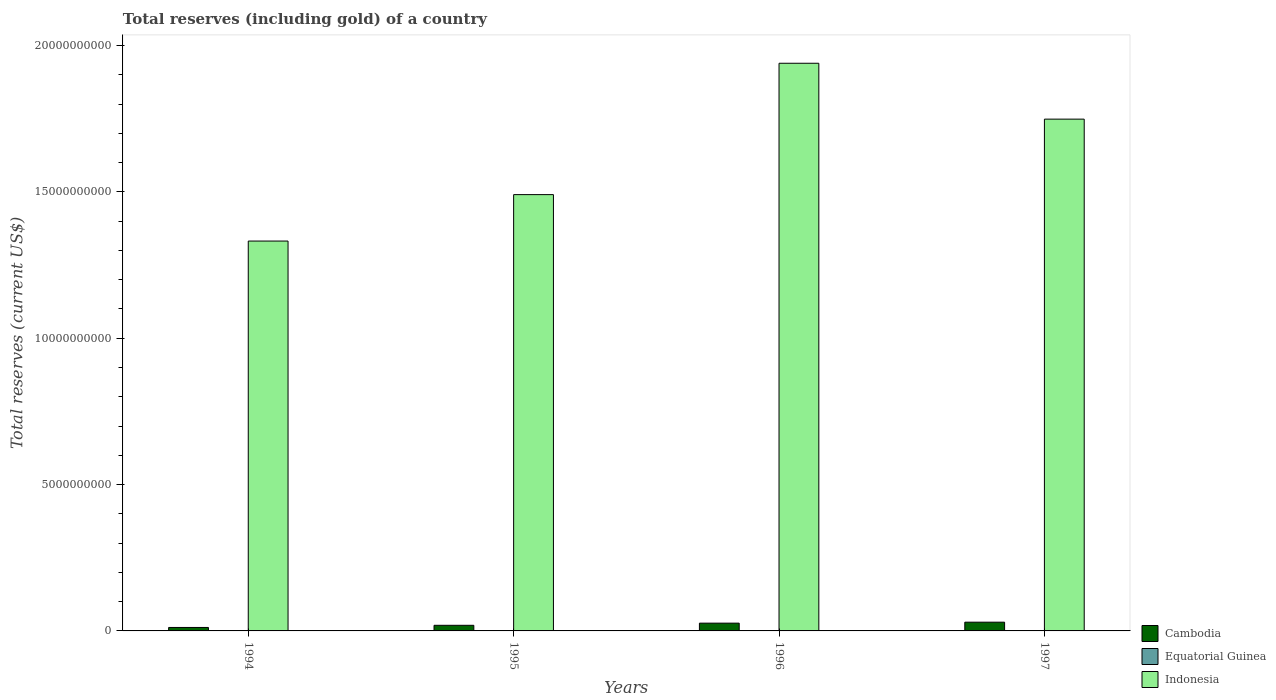How many groups of bars are there?
Offer a very short reply. 4. Are the number of bars per tick equal to the number of legend labels?
Your answer should be compact. Yes. Are the number of bars on each tick of the X-axis equal?
Keep it short and to the point. Yes. In how many cases, is the number of bars for a given year not equal to the number of legend labels?
Your answer should be very brief. 0. What is the total reserves (including gold) in Cambodia in 1997?
Provide a succinct answer. 2.99e+08. Across all years, what is the maximum total reserves (including gold) in Equatorial Guinea?
Your answer should be compact. 4.93e+06. Across all years, what is the minimum total reserves (including gold) in Equatorial Guinea?
Your response must be concise. 4.08e+04. In which year was the total reserves (including gold) in Indonesia minimum?
Make the answer very short. 1994. What is the total total reserves (including gold) in Cambodia in the graph?
Ensure brevity in your answer.  8.75e+08. What is the difference between the total reserves (including gold) in Equatorial Guinea in 1996 and that in 1997?
Give a very brief answer. -4.42e+06. What is the difference between the total reserves (including gold) in Equatorial Guinea in 1997 and the total reserves (including gold) in Cambodia in 1995?
Your response must be concise. -1.87e+08. What is the average total reserves (including gold) in Equatorial Guinea per year?
Give a very brief answer. 1.47e+06. In the year 1994, what is the difference between the total reserves (including gold) in Equatorial Guinea and total reserves (including gold) in Cambodia?
Offer a terse response. -1.18e+08. In how many years, is the total reserves (including gold) in Cambodia greater than 4000000000 US$?
Provide a short and direct response. 0. What is the ratio of the total reserves (including gold) in Cambodia in 1995 to that in 1997?
Your response must be concise. 0.64. What is the difference between the highest and the second highest total reserves (including gold) in Cambodia?
Your response must be concise. 3.29e+07. What is the difference between the highest and the lowest total reserves (including gold) in Cambodia?
Keep it short and to the point. 1.80e+08. In how many years, is the total reserves (including gold) in Cambodia greater than the average total reserves (including gold) in Cambodia taken over all years?
Your answer should be very brief. 2. Is the sum of the total reserves (including gold) in Indonesia in 1994 and 1997 greater than the maximum total reserves (including gold) in Cambodia across all years?
Give a very brief answer. Yes. What does the 1st bar from the left in 1994 represents?
Offer a terse response. Cambodia. Are all the bars in the graph horizontal?
Ensure brevity in your answer.  No. Does the graph contain any zero values?
Your response must be concise. No. Does the graph contain grids?
Your answer should be compact. No. What is the title of the graph?
Offer a very short reply. Total reserves (including gold) of a country. What is the label or title of the X-axis?
Ensure brevity in your answer.  Years. What is the label or title of the Y-axis?
Make the answer very short. Total reserves (current US$). What is the Total reserves (current US$) in Cambodia in 1994?
Offer a terse response. 1.18e+08. What is the Total reserves (current US$) in Equatorial Guinea in 1994?
Offer a terse response. 3.90e+05. What is the Total reserves (current US$) in Indonesia in 1994?
Your response must be concise. 1.33e+1. What is the Total reserves (current US$) in Cambodia in 1995?
Make the answer very short. 1.92e+08. What is the Total reserves (current US$) in Equatorial Guinea in 1995?
Provide a succinct answer. 4.08e+04. What is the Total reserves (current US$) in Indonesia in 1995?
Provide a succinct answer. 1.49e+1. What is the Total reserves (current US$) in Cambodia in 1996?
Your answer should be compact. 2.66e+08. What is the Total reserves (current US$) of Equatorial Guinea in 1996?
Ensure brevity in your answer.  5.16e+05. What is the Total reserves (current US$) in Indonesia in 1996?
Provide a succinct answer. 1.94e+1. What is the Total reserves (current US$) of Cambodia in 1997?
Your response must be concise. 2.99e+08. What is the Total reserves (current US$) of Equatorial Guinea in 1997?
Offer a very short reply. 4.93e+06. What is the Total reserves (current US$) in Indonesia in 1997?
Provide a short and direct response. 1.75e+1. Across all years, what is the maximum Total reserves (current US$) of Cambodia?
Your answer should be compact. 2.99e+08. Across all years, what is the maximum Total reserves (current US$) in Equatorial Guinea?
Make the answer very short. 4.93e+06. Across all years, what is the maximum Total reserves (current US$) of Indonesia?
Your answer should be very brief. 1.94e+1. Across all years, what is the minimum Total reserves (current US$) in Cambodia?
Your answer should be compact. 1.18e+08. Across all years, what is the minimum Total reserves (current US$) in Equatorial Guinea?
Your answer should be very brief. 4.08e+04. Across all years, what is the minimum Total reserves (current US$) of Indonesia?
Give a very brief answer. 1.33e+1. What is the total Total reserves (current US$) in Cambodia in the graph?
Make the answer very short. 8.75e+08. What is the total Total reserves (current US$) in Equatorial Guinea in the graph?
Ensure brevity in your answer.  5.88e+06. What is the total Total reserves (current US$) of Indonesia in the graph?
Give a very brief answer. 6.51e+1. What is the difference between the Total reserves (current US$) in Cambodia in 1994 and that in 1995?
Give a very brief answer. -7.35e+07. What is the difference between the Total reserves (current US$) in Equatorial Guinea in 1994 and that in 1995?
Offer a terse response. 3.50e+05. What is the difference between the Total reserves (current US$) of Indonesia in 1994 and that in 1995?
Keep it short and to the point. -1.59e+09. What is the difference between the Total reserves (current US$) in Cambodia in 1994 and that in 1996?
Your answer should be compact. -1.47e+08. What is the difference between the Total reserves (current US$) in Equatorial Guinea in 1994 and that in 1996?
Provide a short and direct response. -1.26e+05. What is the difference between the Total reserves (current US$) of Indonesia in 1994 and that in 1996?
Your answer should be compact. -6.08e+09. What is the difference between the Total reserves (current US$) of Cambodia in 1994 and that in 1997?
Your response must be concise. -1.80e+08. What is the difference between the Total reserves (current US$) of Equatorial Guinea in 1994 and that in 1997?
Provide a succinct answer. -4.54e+06. What is the difference between the Total reserves (current US$) of Indonesia in 1994 and that in 1997?
Provide a succinct answer. -4.17e+09. What is the difference between the Total reserves (current US$) of Cambodia in 1995 and that in 1996?
Your answer should be compact. -7.38e+07. What is the difference between the Total reserves (current US$) of Equatorial Guinea in 1995 and that in 1996?
Give a very brief answer. -4.76e+05. What is the difference between the Total reserves (current US$) of Indonesia in 1995 and that in 1996?
Give a very brief answer. -4.49e+09. What is the difference between the Total reserves (current US$) in Cambodia in 1995 and that in 1997?
Keep it short and to the point. -1.07e+08. What is the difference between the Total reserves (current US$) of Equatorial Guinea in 1995 and that in 1997?
Provide a short and direct response. -4.89e+06. What is the difference between the Total reserves (current US$) in Indonesia in 1995 and that in 1997?
Make the answer very short. -2.58e+09. What is the difference between the Total reserves (current US$) in Cambodia in 1996 and that in 1997?
Offer a very short reply. -3.29e+07. What is the difference between the Total reserves (current US$) of Equatorial Guinea in 1996 and that in 1997?
Keep it short and to the point. -4.42e+06. What is the difference between the Total reserves (current US$) of Indonesia in 1996 and that in 1997?
Your answer should be very brief. 1.91e+09. What is the difference between the Total reserves (current US$) of Cambodia in 1994 and the Total reserves (current US$) of Equatorial Guinea in 1995?
Keep it short and to the point. 1.18e+08. What is the difference between the Total reserves (current US$) of Cambodia in 1994 and the Total reserves (current US$) of Indonesia in 1995?
Offer a terse response. -1.48e+1. What is the difference between the Total reserves (current US$) of Equatorial Guinea in 1994 and the Total reserves (current US$) of Indonesia in 1995?
Your answer should be very brief. -1.49e+1. What is the difference between the Total reserves (current US$) of Cambodia in 1994 and the Total reserves (current US$) of Equatorial Guinea in 1996?
Your answer should be very brief. 1.18e+08. What is the difference between the Total reserves (current US$) of Cambodia in 1994 and the Total reserves (current US$) of Indonesia in 1996?
Provide a succinct answer. -1.93e+1. What is the difference between the Total reserves (current US$) of Equatorial Guinea in 1994 and the Total reserves (current US$) of Indonesia in 1996?
Your answer should be compact. -1.94e+1. What is the difference between the Total reserves (current US$) of Cambodia in 1994 and the Total reserves (current US$) of Equatorial Guinea in 1997?
Provide a short and direct response. 1.14e+08. What is the difference between the Total reserves (current US$) in Cambodia in 1994 and the Total reserves (current US$) in Indonesia in 1997?
Your answer should be compact. -1.74e+1. What is the difference between the Total reserves (current US$) of Equatorial Guinea in 1994 and the Total reserves (current US$) of Indonesia in 1997?
Ensure brevity in your answer.  -1.75e+1. What is the difference between the Total reserves (current US$) in Cambodia in 1995 and the Total reserves (current US$) in Equatorial Guinea in 1996?
Your response must be concise. 1.91e+08. What is the difference between the Total reserves (current US$) of Cambodia in 1995 and the Total reserves (current US$) of Indonesia in 1996?
Provide a short and direct response. -1.92e+1. What is the difference between the Total reserves (current US$) of Equatorial Guinea in 1995 and the Total reserves (current US$) of Indonesia in 1996?
Your answer should be very brief. -1.94e+1. What is the difference between the Total reserves (current US$) of Cambodia in 1995 and the Total reserves (current US$) of Equatorial Guinea in 1997?
Ensure brevity in your answer.  1.87e+08. What is the difference between the Total reserves (current US$) in Cambodia in 1995 and the Total reserves (current US$) in Indonesia in 1997?
Provide a short and direct response. -1.73e+1. What is the difference between the Total reserves (current US$) of Equatorial Guinea in 1995 and the Total reserves (current US$) of Indonesia in 1997?
Your response must be concise. -1.75e+1. What is the difference between the Total reserves (current US$) in Cambodia in 1996 and the Total reserves (current US$) in Equatorial Guinea in 1997?
Keep it short and to the point. 2.61e+08. What is the difference between the Total reserves (current US$) of Cambodia in 1996 and the Total reserves (current US$) of Indonesia in 1997?
Your response must be concise. -1.72e+1. What is the difference between the Total reserves (current US$) of Equatorial Guinea in 1996 and the Total reserves (current US$) of Indonesia in 1997?
Offer a very short reply. -1.75e+1. What is the average Total reserves (current US$) in Cambodia per year?
Ensure brevity in your answer.  2.19e+08. What is the average Total reserves (current US$) in Equatorial Guinea per year?
Your answer should be compact. 1.47e+06. What is the average Total reserves (current US$) of Indonesia per year?
Offer a very short reply. 1.63e+1. In the year 1994, what is the difference between the Total reserves (current US$) of Cambodia and Total reserves (current US$) of Equatorial Guinea?
Provide a succinct answer. 1.18e+08. In the year 1994, what is the difference between the Total reserves (current US$) in Cambodia and Total reserves (current US$) in Indonesia?
Keep it short and to the point. -1.32e+1. In the year 1994, what is the difference between the Total reserves (current US$) of Equatorial Guinea and Total reserves (current US$) of Indonesia?
Your answer should be compact. -1.33e+1. In the year 1995, what is the difference between the Total reserves (current US$) in Cambodia and Total reserves (current US$) in Equatorial Guinea?
Your response must be concise. 1.92e+08. In the year 1995, what is the difference between the Total reserves (current US$) of Cambodia and Total reserves (current US$) of Indonesia?
Your response must be concise. -1.47e+1. In the year 1995, what is the difference between the Total reserves (current US$) in Equatorial Guinea and Total reserves (current US$) in Indonesia?
Ensure brevity in your answer.  -1.49e+1. In the year 1996, what is the difference between the Total reserves (current US$) of Cambodia and Total reserves (current US$) of Equatorial Guinea?
Make the answer very short. 2.65e+08. In the year 1996, what is the difference between the Total reserves (current US$) in Cambodia and Total reserves (current US$) in Indonesia?
Ensure brevity in your answer.  -1.91e+1. In the year 1996, what is the difference between the Total reserves (current US$) in Equatorial Guinea and Total reserves (current US$) in Indonesia?
Your response must be concise. -1.94e+1. In the year 1997, what is the difference between the Total reserves (current US$) of Cambodia and Total reserves (current US$) of Equatorial Guinea?
Ensure brevity in your answer.  2.94e+08. In the year 1997, what is the difference between the Total reserves (current US$) in Cambodia and Total reserves (current US$) in Indonesia?
Your answer should be very brief. -1.72e+1. In the year 1997, what is the difference between the Total reserves (current US$) in Equatorial Guinea and Total reserves (current US$) in Indonesia?
Offer a terse response. -1.75e+1. What is the ratio of the Total reserves (current US$) of Cambodia in 1994 to that in 1995?
Keep it short and to the point. 0.62. What is the ratio of the Total reserves (current US$) in Equatorial Guinea in 1994 to that in 1995?
Ensure brevity in your answer.  9.56. What is the ratio of the Total reserves (current US$) in Indonesia in 1994 to that in 1995?
Keep it short and to the point. 0.89. What is the ratio of the Total reserves (current US$) in Cambodia in 1994 to that in 1996?
Your answer should be very brief. 0.45. What is the ratio of the Total reserves (current US$) in Equatorial Guinea in 1994 to that in 1996?
Your answer should be very brief. 0.76. What is the ratio of the Total reserves (current US$) in Indonesia in 1994 to that in 1996?
Offer a terse response. 0.69. What is the ratio of the Total reserves (current US$) of Cambodia in 1994 to that in 1997?
Your answer should be very brief. 0.4. What is the ratio of the Total reserves (current US$) in Equatorial Guinea in 1994 to that in 1997?
Give a very brief answer. 0.08. What is the ratio of the Total reserves (current US$) in Indonesia in 1994 to that in 1997?
Give a very brief answer. 0.76. What is the ratio of the Total reserves (current US$) in Cambodia in 1995 to that in 1996?
Your answer should be very brief. 0.72. What is the ratio of the Total reserves (current US$) in Equatorial Guinea in 1995 to that in 1996?
Give a very brief answer. 0.08. What is the ratio of the Total reserves (current US$) of Indonesia in 1995 to that in 1996?
Offer a terse response. 0.77. What is the ratio of the Total reserves (current US$) in Cambodia in 1995 to that in 1997?
Provide a short and direct response. 0.64. What is the ratio of the Total reserves (current US$) in Equatorial Guinea in 1995 to that in 1997?
Make the answer very short. 0.01. What is the ratio of the Total reserves (current US$) of Indonesia in 1995 to that in 1997?
Offer a terse response. 0.85. What is the ratio of the Total reserves (current US$) of Cambodia in 1996 to that in 1997?
Provide a short and direct response. 0.89. What is the ratio of the Total reserves (current US$) of Equatorial Guinea in 1996 to that in 1997?
Ensure brevity in your answer.  0.1. What is the ratio of the Total reserves (current US$) of Indonesia in 1996 to that in 1997?
Ensure brevity in your answer.  1.11. What is the difference between the highest and the second highest Total reserves (current US$) in Cambodia?
Keep it short and to the point. 3.29e+07. What is the difference between the highest and the second highest Total reserves (current US$) of Equatorial Guinea?
Your response must be concise. 4.42e+06. What is the difference between the highest and the second highest Total reserves (current US$) of Indonesia?
Provide a succinct answer. 1.91e+09. What is the difference between the highest and the lowest Total reserves (current US$) of Cambodia?
Provide a short and direct response. 1.80e+08. What is the difference between the highest and the lowest Total reserves (current US$) of Equatorial Guinea?
Offer a very short reply. 4.89e+06. What is the difference between the highest and the lowest Total reserves (current US$) in Indonesia?
Make the answer very short. 6.08e+09. 